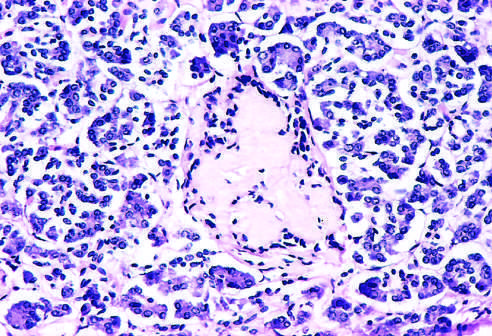s amyloidosis observed late in the natural history of this form of diabetes, with islet inflammation noted at earlier observations?
Answer the question using a single word or phrase. Yes 